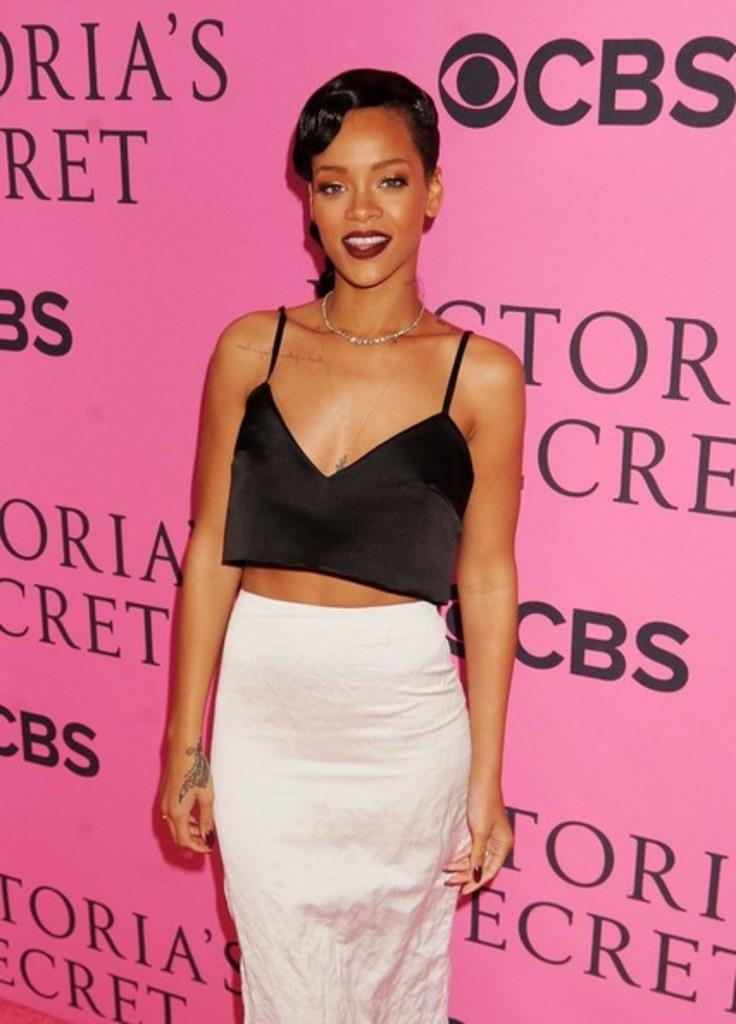Who is the main subject in the picture? There is a girl in the picture. What is the girl wearing? The girl is wearing a black and white dress. What expression does the girl have? The girl is smiling. What is the girl doing in the picture? The girl is posing for the photo. What can be seen in the background of the picture? There is a pink color board in the background. What is written on the pink color board? There is text written on the pink color board. What type of jar is the girl holding in the picture? There is no jar present in the image; the girl is not holding anything. What instrument is the girl playing in the picture? There is no guitar or any musical instrument present in the image; the girl is simply posing for the photo. 